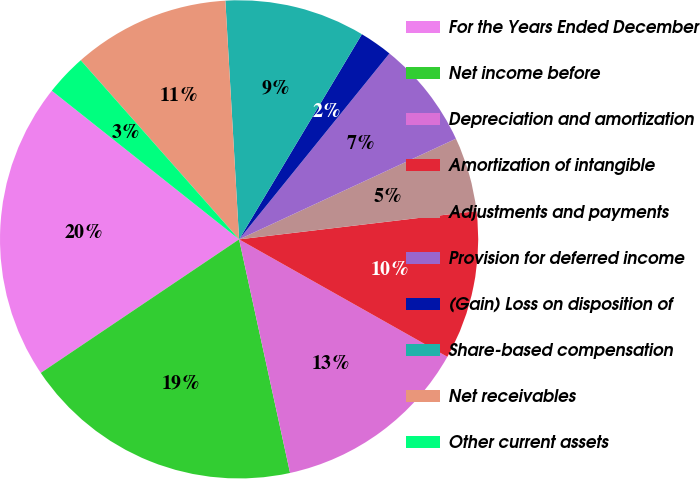Convert chart. <chart><loc_0><loc_0><loc_500><loc_500><pie_chart><fcel>For the Years Ended December<fcel>Net income before<fcel>Depreciation and amortization<fcel>Amortization of intangible<fcel>Adjustments and payments<fcel>Provision for deferred income<fcel>(Gain) Loss on disposition of<fcel>Share-based compensation<fcel>Net receivables<fcel>Other current assets<nl><fcel>20.11%<fcel>18.99%<fcel>13.41%<fcel>10.06%<fcel>5.03%<fcel>7.26%<fcel>2.24%<fcel>9.5%<fcel>10.61%<fcel>2.8%<nl></chart> 